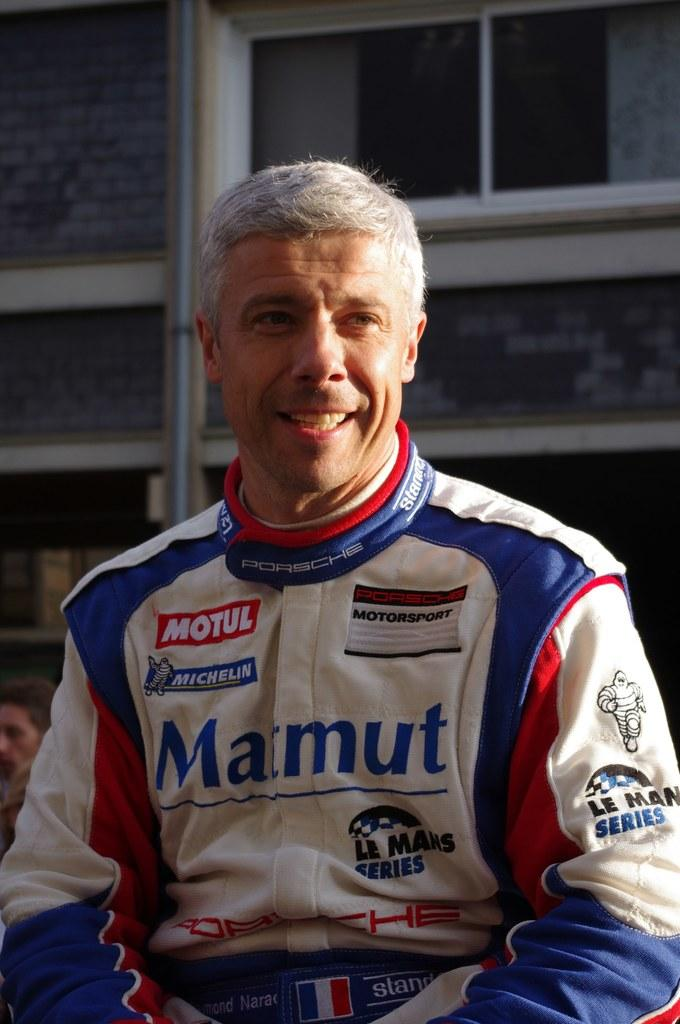<image>
Provide a brief description of the given image. A race car driver with grey hair and a Marmut jacket is smiling. 